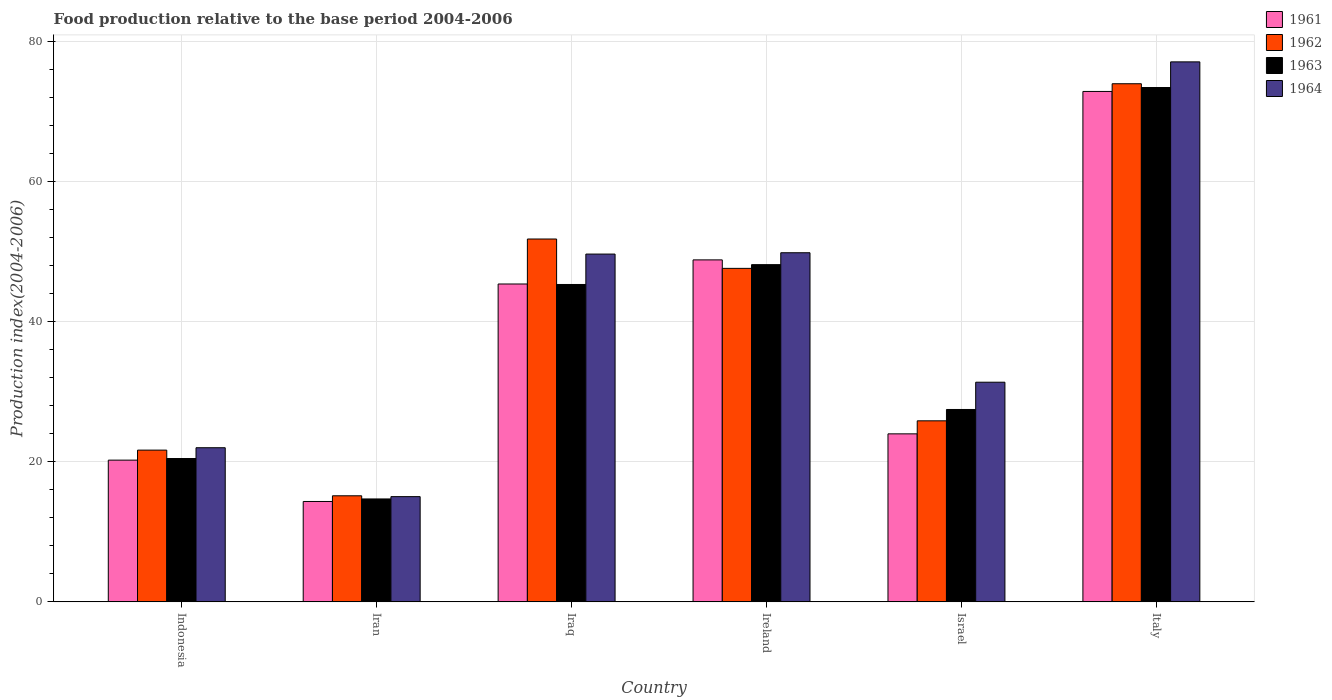How many different coloured bars are there?
Give a very brief answer. 4. Are the number of bars per tick equal to the number of legend labels?
Your answer should be compact. Yes. How many bars are there on the 2nd tick from the right?
Make the answer very short. 4. What is the label of the 5th group of bars from the left?
Your answer should be compact. Israel. What is the food production index in 1963 in Israel?
Keep it short and to the point. 27.46. Across all countries, what is the maximum food production index in 1962?
Make the answer very short. 73.95. Across all countries, what is the minimum food production index in 1964?
Your answer should be compact. 15.02. In which country was the food production index in 1964 minimum?
Provide a short and direct response. Iran. What is the total food production index in 1961 in the graph?
Give a very brief answer. 225.57. What is the difference between the food production index in 1961 in Indonesia and that in Israel?
Keep it short and to the point. -3.75. What is the difference between the food production index in 1963 in Iran and the food production index in 1964 in Israel?
Offer a very short reply. -16.66. What is the average food production index in 1963 per country?
Your response must be concise. 38.24. What is the difference between the food production index of/in 1962 and food production index of/in 1964 in Ireland?
Make the answer very short. -2.23. What is the ratio of the food production index in 1961 in Iraq to that in Ireland?
Provide a succinct answer. 0.93. Is the food production index in 1961 in Indonesia less than that in Iraq?
Keep it short and to the point. Yes. What is the difference between the highest and the second highest food production index in 1964?
Provide a succinct answer. -27.24. What is the difference between the highest and the lowest food production index in 1963?
Offer a very short reply. 58.72. In how many countries, is the food production index in 1963 greater than the average food production index in 1963 taken over all countries?
Provide a short and direct response. 3. Is the sum of the food production index in 1961 in Iran and Italy greater than the maximum food production index in 1964 across all countries?
Give a very brief answer. Yes. What does the 4th bar from the left in Iran represents?
Keep it short and to the point. 1964. What does the 2nd bar from the right in Iran represents?
Keep it short and to the point. 1963. How many bars are there?
Ensure brevity in your answer.  24. Are all the bars in the graph horizontal?
Ensure brevity in your answer.  No. What is the difference between two consecutive major ticks on the Y-axis?
Offer a very short reply. 20. Are the values on the major ticks of Y-axis written in scientific E-notation?
Give a very brief answer. No. How are the legend labels stacked?
Make the answer very short. Vertical. What is the title of the graph?
Give a very brief answer. Food production relative to the base period 2004-2006. What is the label or title of the X-axis?
Offer a very short reply. Country. What is the label or title of the Y-axis?
Offer a very short reply. Production index(2004-2006). What is the Production index(2004-2006) of 1961 in Indonesia?
Your answer should be very brief. 20.23. What is the Production index(2004-2006) in 1962 in Indonesia?
Offer a very short reply. 21.66. What is the Production index(2004-2006) of 1963 in Indonesia?
Ensure brevity in your answer.  20.46. What is the Production index(2004-2006) of 1964 in Indonesia?
Offer a very short reply. 22. What is the Production index(2004-2006) in 1961 in Iran?
Provide a succinct answer. 14.33. What is the Production index(2004-2006) in 1962 in Iran?
Your response must be concise. 15.14. What is the Production index(2004-2006) in 1963 in Iran?
Provide a succinct answer. 14.69. What is the Production index(2004-2006) of 1964 in Iran?
Your response must be concise. 15.02. What is the Production index(2004-2006) of 1961 in Iraq?
Your response must be concise. 45.37. What is the Production index(2004-2006) of 1962 in Iraq?
Provide a succinct answer. 51.79. What is the Production index(2004-2006) in 1963 in Iraq?
Ensure brevity in your answer.  45.3. What is the Production index(2004-2006) of 1964 in Iraq?
Offer a terse response. 49.64. What is the Production index(2004-2006) in 1961 in Ireland?
Your response must be concise. 48.81. What is the Production index(2004-2006) of 1962 in Ireland?
Your response must be concise. 47.6. What is the Production index(2004-2006) in 1963 in Ireland?
Make the answer very short. 48.13. What is the Production index(2004-2006) of 1964 in Ireland?
Give a very brief answer. 49.83. What is the Production index(2004-2006) in 1961 in Israel?
Your answer should be very brief. 23.98. What is the Production index(2004-2006) in 1962 in Israel?
Make the answer very short. 25.84. What is the Production index(2004-2006) in 1963 in Israel?
Keep it short and to the point. 27.46. What is the Production index(2004-2006) in 1964 in Israel?
Offer a terse response. 31.35. What is the Production index(2004-2006) of 1961 in Italy?
Provide a short and direct response. 72.85. What is the Production index(2004-2006) in 1962 in Italy?
Your answer should be compact. 73.95. What is the Production index(2004-2006) of 1963 in Italy?
Provide a short and direct response. 73.41. What is the Production index(2004-2006) of 1964 in Italy?
Make the answer very short. 77.07. Across all countries, what is the maximum Production index(2004-2006) in 1961?
Your answer should be compact. 72.85. Across all countries, what is the maximum Production index(2004-2006) of 1962?
Ensure brevity in your answer.  73.95. Across all countries, what is the maximum Production index(2004-2006) of 1963?
Make the answer very short. 73.41. Across all countries, what is the maximum Production index(2004-2006) in 1964?
Provide a short and direct response. 77.07. Across all countries, what is the minimum Production index(2004-2006) in 1961?
Give a very brief answer. 14.33. Across all countries, what is the minimum Production index(2004-2006) of 1962?
Provide a succinct answer. 15.14. Across all countries, what is the minimum Production index(2004-2006) in 1963?
Provide a succinct answer. 14.69. Across all countries, what is the minimum Production index(2004-2006) of 1964?
Your answer should be compact. 15.02. What is the total Production index(2004-2006) in 1961 in the graph?
Keep it short and to the point. 225.57. What is the total Production index(2004-2006) in 1962 in the graph?
Offer a terse response. 235.98. What is the total Production index(2004-2006) of 1963 in the graph?
Give a very brief answer. 229.45. What is the total Production index(2004-2006) in 1964 in the graph?
Provide a succinct answer. 244.91. What is the difference between the Production index(2004-2006) in 1962 in Indonesia and that in Iran?
Provide a short and direct response. 6.52. What is the difference between the Production index(2004-2006) in 1963 in Indonesia and that in Iran?
Provide a succinct answer. 5.77. What is the difference between the Production index(2004-2006) in 1964 in Indonesia and that in Iran?
Provide a succinct answer. 6.98. What is the difference between the Production index(2004-2006) in 1961 in Indonesia and that in Iraq?
Your response must be concise. -25.14. What is the difference between the Production index(2004-2006) of 1962 in Indonesia and that in Iraq?
Make the answer very short. -30.13. What is the difference between the Production index(2004-2006) of 1963 in Indonesia and that in Iraq?
Offer a very short reply. -24.84. What is the difference between the Production index(2004-2006) in 1964 in Indonesia and that in Iraq?
Offer a terse response. -27.64. What is the difference between the Production index(2004-2006) of 1961 in Indonesia and that in Ireland?
Your answer should be very brief. -28.58. What is the difference between the Production index(2004-2006) in 1962 in Indonesia and that in Ireland?
Your answer should be compact. -25.94. What is the difference between the Production index(2004-2006) in 1963 in Indonesia and that in Ireland?
Give a very brief answer. -27.67. What is the difference between the Production index(2004-2006) in 1964 in Indonesia and that in Ireland?
Provide a short and direct response. -27.83. What is the difference between the Production index(2004-2006) of 1961 in Indonesia and that in Israel?
Offer a very short reply. -3.75. What is the difference between the Production index(2004-2006) in 1962 in Indonesia and that in Israel?
Offer a very short reply. -4.18. What is the difference between the Production index(2004-2006) in 1964 in Indonesia and that in Israel?
Give a very brief answer. -9.35. What is the difference between the Production index(2004-2006) of 1961 in Indonesia and that in Italy?
Your answer should be very brief. -52.62. What is the difference between the Production index(2004-2006) in 1962 in Indonesia and that in Italy?
Your answer should be compact. -52.29. What is the difference between the Production index(2004-2006) in 1963 in Indonesia and that in Italy?
Offer a very short reply. -52.95. What is the difference between the Production index(2004-2006) of 1964 in Indonesia and that in Italy?
Provide a succinct answer. -55.07. What is the difference between the Production index(2004-2006) in 1961 in Iran and that in Iraq?
Provide a short and direct response. -31.04. What is the difference between the Production index(2004-2006) of 1962 in Iran and that in Iraq?
Provide a short and direct response. -36.65. What is the difference between the Production index(2004-2006) of 1963 in Iran and that in Iraq?
Provide a short and direct response. -30.61. What is the difference between the Production index(2004-2006) in 1964 in Iran and that in Iraq?
Provide a succinct answer. -34.62. What is the difference between the Production index(2004-2006) of 1961 in Iran and that in Ireland?
Ensure brevity in your answer.  -34.48. What is the difference between the Production index(2004-2006) of 1962 in Iran and that in Ireland?
Give a very brief answer. -32.46. What is the difference between the Production index(2004-2006) in 1963 in Iran and that in Ireland?
Provide a short and direct response. -33.44. What is the difference between the Production index(2004-2006) in 1964 in Iran and that in Ireland?
Offer a very short reply. -34.81. What is the difference between the Production index(2004-2006) of 1961 in Iran and that in Israel?
Give a very brief answer. -9.65. What is the difference between the Production index(2004-2006) of 1963 in Iran and that in Israel?
Provide a short and direct response. -12.77. What is the difference between the Production index(2004-2006) of 1964 in Iran and that in Israel?
Keep it short and to the point. -16.33. What is the difference between the Production index(2004-2006) in 1961 in Iran and that in Italy?
Provide a short and direct response. -58.52. What is the difference between the Production index(2004-2006) in 1962 in Iran and that in Italy?
Your answer should be very brief. -58.81. What is the difference between the Production index(2004-2006) of 1963 in Iran and that in Italy?
Give a very brief answer. -58.72. What is the difference between the Production index(2004-2006) of 1964 in Iran and that in Italy?
Your response must be concise. -62.05. What is the difference between the Production index(2004-2006) in 1961 in Iraq and that in Ireland?
Provide a short and direct response. -3.44. What is the difference between the Production index(2004-2006) in 1962 in Iraq and that in Ireland?
Keep it short and to the point. 4.19. What is the difference between the Production index(2004-2006) in 1963 in Iraq and that in Ireland?
Ensure brevity in your answer.  -2.83. What is the difference between the Production index(2004-2006) of 1964 in Iraq and that in Ireland?
Your response must be concise. -0.19. What is the difference between the Production index(2004-2006) in 1961 in Iraq and that in Israel?
Ensure brevity in your answer.  21.39. What is the difference between the Production index(2004-2006) of 1962 in Iraq and that in Israel?
Make the answer very short. 25.95. What is the difference between the Production index(2004-2006) of 1963 in Iraq and that in Israel?
Offer a terse response. 17.84. What is the difference between the Production index(2004-2006) of 1964 in Iraq and that in Israel?
Ensure brevity in your answer.  18.29. What is the difference between the Production index(2004-2006) of 1961 in Iraq and that in Italy?
Your response must be concise. -27.48. What is the difference between the Production index(2004-2006) in 1962 in Iraq and that in Italy?
Offer a terse response. -22.16. What is the difference between the Production index(2004-2006) in 1963 in Iraq and that in Italy?
Provide a succinct answer. -28.11. What is the difference between the Production index(2004-2006) in 1964 in Iraq and that in Italy?
Ensure brevity in your answer.  -27.43. What is the difference between the Production index(2004-2006) in 1961 in Ireland and that in Israel?
Offer a very short reply. 24.83. What is the difference between the Production index(2004-2006) in 1962 in Ireland and that in Israel?
Your response must be concise. 21.76. What is the difference between the Production index(2004-2006) of 1963 in Ireland and that in Israel?
Your answer should be compact. 20.67. What is the difference between the Production index(2004-2006) in 1964 in Ireland and that in Israel?
Your answer should be very brief. 18.48. What is the difference between the Production index(2004-2006) in 1961 in Ireland and that in Italy?
Keep it short and to the point. -24.04. What is the difference between the Production index(2004-2006) in 1962 in Ireland and that in Italy?
Ensure brevity in your answer.  -26.35. What is the difference between the Production index(2004-2006) in 1963 in Ireland and that in Italy?
Your response must be concise. -25.28. What is the difference between the Production index(2004-2006) of 1964 in Ireland and that in Italy?
Offer a very short reply. -27.24. What is the difference between the Production index(2004-2006) of 1961 in Israel and that in Italy?
Give a very brief answer. -48.87. What is the difference between the Production index(2004-2006) of 1962 in Israel and that in Italy?
Provide a short and direct response. -48.11. What is the difference between the Production index(2004-2006) of 1963 in Israel and that in Italy?
Keep it short and to the point. -45.95. What is the difference between the Production index(2004-2006) in 1964 in Israel and that in Italy?
Your answer should be compact. -45.72. What is the difference between the Production index(2004-2006) in 1961 in Indonesia and the Production index(2004-2006) in 1962 in Iran?
Give a very brief answer. 5.09. What is the difference between the Production index(2004-2006) of 1961 in Indonesia and the Production index(2004-2006) of 1963 in Iran?
Ensure brevity in your answer.  5.54. What is the difference between the Production index(2004-2006) in 1961 in Indonesia and the Production index(2004-2006) in 1964 in Iran?
Ensure brevity in your answer.  5.21. What is the difference between the Production index(2004-2006) in 1962 in Indonesia and the Production index(2004-2006) in 1963 in Iran?
Your response must be concise. 6.97. What is the difference between the Production index(2004-2006) in 1962 in Indonesia and the Production index(2004-2006) in 1964 in Iran?
Your response must be concise. 6.64. What is the difference between the Production index(2004-2006) in 1963 in Indonesia and the Production index(2004-2006) in 1964 in Iran?
Your answer should be compact. 5.44. What is the difference between the Production index(2004-2006) in 1961 in Indonesia and the Production index(2004-2006) in 1962 in Iraq?
Offer a very short reply. -31.56. What is the difference between the Production index(2004-2006) of 1961 in Indonesia and the Production index(2004-2006) of 1963 in Iraq?
Ensure brevity in your answer.  -25.07. What is the difference between the Production index(2004-2006) of 1961 in Indonesia and the Production index(2004-2006) of 1964 in Iraq?
Ensure brevity in your answer.  -29.41. What is the difference between the Production index(2004-2006) of 1962 in Indonesia and the Production index(2004-2006) of 1963 in Iraq?
Provide a short and direct response. -23.64. What is the difference between the Production index(2004-2006) in 1962 in Indonesia and the Production index(2004-2006) in 1964 in Iraq?
Provide a succinct answer. -27.98. What is the difference between the Production index(2004-2006) of 1963 in Indonesia and the Production index(2004-2006) of 1964 in Iraq?
Your answer should be compact. -29.18. What is the difference between the Production index(2004-2006) in 1961 in Indonesia and the Production index(2004-2006) in 1962 in Ireland?
Your answer should be very brief. -27.37. What is the difference between the Production index(2004-2006) in 1961 in Indonesia and the Production index(2004-2006) in 1963 in Ireland?
Your response must be concise. -27.9. What is the difference between the Production index(2004-2006) of 1961 in Indonesia and the Production index(2004-2006) of 1964 in Ireland?
Offer a very short reply. -29.6. What is the difference between the Production index(2004-2006) of 1962 in Indonesia and the Production index(2004-2006) of 1963 in Ireland?
Your response must be concise. -26.47. What is the difference between the Production index(2004-2006) of 1962 in Indonesia and the Production index(2004-2006) of 1964 in Ireland?
Make the answer very short. -28.17. What is the difference between the Production index(2004-2006) of 1963 in Indonesia and the Production index(2004-2006) of 1964 in Ireland?
Ensure brevity in your answer.  -29.37. What is the difference between the Production index(2004-2006) in 1961 in Indonesia and the Production index(2004-2006) in 1962 in Israel?
Your answer should be compact. -5.61. What is the difference between the Production index(2004-2006) in 1961 in Indonesia and the Production index(2004-2006) in 1963 in Israel?
Your response must be concise. -7.23. What is the difference between the Production index(2004-2006) of 1961 in Indonesia and the Production index(2004-2006) of 1964 in Israel?
Ensure brevity in your answer.  -11.12. What is the difference between the Production index(2004-2006) in 1962 in Indonesia and the Production index(2004-2006) in 1963 in Israel?
Make the answer very short. -5.8. What is the difference between the Production index(2004-2006) of 1962 in Indonesia and the Production index(2004-2006) of 1964 in Israel?
Make the answer very short. -9.69. What is the difference between the Production index(2004-2006) in 1963 in Indonesia and the Production index(2004-2006) in 1964 in Israel?
Your response must be concise. -10.89. What is the difference between the Production index(2004-2006) of 1961 in Indonesia and the Production index(2004-2006) of 1962 in Italy?
Make the answer very short. -53.72. What is the difference between the Production index(2004-2006) in 1961 in Indonesia and the Production index(2004-2006) in 1963 in Italy?
Give a very brief answer. -53.18. What is the difference between the Production index(2004-2006) in 1961 in Indonesia and the Production index(2004-2006) in 1964 in Italy?
Keep it short and to the point. -56.84. What is the difference between the Production index(2004-2006) in 1962 in Indonesia and the Production index(2004-2006) in 1963 in Italy?
Provide a short and direct response. -51.75. What is the difference between the Production index(2004-2006) in 1962 in Indonesia and the Production index(2004-2006) in 1964 in Italy?
Your response must be concise. -55.41. What is the difference between the Production index(2004-2006) of 1963 in Indonesia and the Production index(2004-2006) of 1964 in Italy?
Provide a short and direct response. -56.61. What is the difference between the Production index(2004-2006) in 1961 in Iran and the Production index(2004-2006) in 1962 in Iraq?
Your answer should be compact. -37.46. What is the difference between the Production index(2004-2006) of 1961 in Iran and the Production index(2004-2006) of 1963 in Iraq?
Provide a short and direct response. -30.97. What is the difference between the Production index(2004-2006) in 1961 in Iran and the Production index(2004-2006) in 1964 in Iraq?
Offer a very short reply. -35.31. What is the difference between the Production index(2004-2006) of 1962 in Iran and the Production index(2004-2006) of 1963 in Iraq?
Your answer should be very brief. -30.16. What is the difference between the Production index(2004-2006) in 1962 in Iran and the Production index(2004-2006) in 1964 in Iraq?
Keep it short and to the point. -34.5. What is the difference between the Production index(2004-2006) of 1963 in Iran and the Production index(2004-2006) of 1964 in Iraq?
Provide a succinct answer. -34.95. What is the difference between the Production index(2004-2006) of 1961 in Iran and the Production index(2004-2006) of 1962 in Ireland?
Ensure brevity in your answer.  -33.27. What is the difference between the Production index(2004-2006) in 1961 in Iran and the Production index(2004-2006) in 1963 in Ireland?
Your response must be concise. -33.8. What is the difference between the Production index(2004-2006) of 1961 in Iran and the Production index(2004-2006) of 1964 in Ireland?
Offer a terse response. -35.5. What is the difference between the Production index(2004-2006) of 1962 in Iran and the Production index(2004-2006) of 1963 in Ireland?
Ensure brevity in your answer.  -32.99. What is the difference between the Production index(2004-2006) in 1962 in Iran and the Production index(2004-2006) in 1964 in Ireland?
Your response must be concise. -34.69. What is the difference between the Production index(2004-2006) of 1963 in Iran and the Production index(2004-2006) of 1964 in Ireland?
Make the answer very short. -35.14. What is the difference between the Production index(2004-2006) of 1961 in Iran and the Production index(2004-2006) of 1962 in Israel?
Your answer should be compact. -11.51. What is the difference between the Production index(2004-2006) of 1961 in Iran and the Production index(2004-2006) of 1963 in Israel?
Ensure brevity in your answer.  -13.13. What is the difference between the Production index(2004-2006) in 1961 in Iran and the Production index(2004-2006) in 1964 in Israel?
Provide a short and direct response. -17.02. What is the difference between the Production index(2004-2006) of 1962 in Iran and the Production index(2004-2006) of 1963 in Israel?
Your response must be concise. -12.32. What is the difference between the Production index(2004-2006) in 1962 in Iran and the Production index(2004-2006) in 1964 in Israel?
Your answer should be very brief. -16.21. What is the difference between the Production index(2004-2006) of 1963 in Iran and the Production index(2004-2006) of 1964 in Israel?
Your answer should be very brief. -16.66. What is the difference between the Production index(2004-2006) in 1961 in Iran and the Production index(2004-2006) in 1962 in Italy?
Keep it short and to the point. -59.62. What is the difference between the Production index(2004-2006) of 1961 in Iran and the Production index(2004-2006) of 1963 in Italy?
Provide a short and direct response. -59.08. What is the difference between the Production index(2004-2006) of 1961 in Iran and the Production index(2004-2006) of 1964 in Italy?
Your response must be concise. -62.74. What is the difference between the Production index(2004-2006) of 1962 in Iran and the Production index(2004-2006) of 1963 in Italy?
Offer a very short reply. -58.27. What is the difference between the Production index(2004-2006) in 1962 in Iran and the Production index(2004-2006) in 1964 in Italy?
Your answer should be very brief. -61.93. What is the difference between the Production index(2004-2006) in 1963 in Iran and the Production index(2004-2006) in 1964 in Italy?
Give a very brief answer. -62.38. What is the difference between the Production index(2004-2006) in 1961 in Iraq and the Production index(2004-2006) in 1962 in Ireland?
Your answer should be very brief. -2.23. What is the difference between the Production index(2004-2006) of 1961 in Iraq and the Production index(2004-2006) of 1963 in Ireland?
Make the answer very short. -2.76. What is the difference between the Production index(2004-2006) of 1961 in Iraq and the Production index(2004-2006) of 1964 in Ireland?
Offer a terse response. -4.46. What is the difference between the Production index(2004-2006) in 1962 in Iraq and the Production index(2004-2006) in 1963 in Ireland?
Offer a terse response. 3.66. What is the difference between the Production index(2004-2006) in 1962 in Iraq and the Production index(2004-2006) in 1964 in Ireland?
Ensure brevity in your answer.  1.96. What is the difference between the Production index(2004-2006) of 1963 in Iraq and the Production index(2004-2006) of 1964 in Ireland?
Ensure brevity in your answer.  -4.53. What is the difference between the Production index(2004-2006) of 1961 in Iraq and the Production index(2004-2006) of 1962 in Israel?
Give a very brief answer. 19.53. What is the difference between the Production index(2004-2006) in 1961 in Iraq and the Production index(2004-2006) in 1963 in Israel?
Give a very brief answer. 17.91. What is the difference between the Production index(2004-2006) of 1961 in Iraq and the Production index(2004-2006) of 1964 in Israel?
Offer a very short reply. 14.02. What is the difference between the Production index(2004-2006) of 1962 in Iraq and the Production index(2004-2006) of 1963 in Israel?
Make the answer very short. 24.33. What is the difference between the Production index(2004-2006) of 1962 in Iraq and the Production index(2004-2006) of 1964 in Israel?
Give a very brief answer. 20.44. What is the difference between the Production index(2004-2006) of 1963 in Iraq and the Production index(2004-2006) of 1964 in Israel?
Your response must be concise. 13.95. What is the difference between the Production index(2004-2006) in 1961 in Iraq and the Production index(2004-2006) in 1962 in Italy?
Your response must be concise. -28.58. What is the difference between the Production index(2004-2006) of 1961 in Iraq and the Production index(2004-2006) of 1963 in Italy?
Make the answer very short. -28.04. What is the difference between the Production index(2004-2006) of 1961 in Iraq and the Production index(2004-2006) of 1964 in Italy?
Offer a terse response. -31.7. What is the difference between the Production index(2004-2006) in 1962 in Iraq and the Production index(2004-2006) in 1963 in Italy?
Provide a short and direct response. -21.62. What is the difference between the Production index(2004-2006) of 1962 in Iraq and the Production index(2004-2006) of 1964 in Italy?
Offer a terse response. -25.28. What is the difference between the Production index(2004-2006) in 1963 in Iraq and the Production index(2004-2006) in 1964 in Italy?
Offer a very short reply. -31.77. What is the difference between the Production index(2004-2006) of 1961 in Ireland and the Production index(2004-2006) of 1962 in Israel?
Offer a terse response. 22.97. What is the difference between the Production index(2004-2006) of 1961 in Ireland and the Production index(2004-2006) of 1963 in Israel?
Your response must be concise. 21.35. What is the difference between the Production index(2004-2006) in 1961 in Ireland and the Production index(2004-2006) in 1964 in Israel?
Offer a very short reply. 17.46. What is the difference between the Production index(2004-2006) of 1962 in Ireland and the Production index(2004-2006) of 1963 in Israel?
Keep it short and to the point. 20.14. What is the difference between the Production index(2004-2006) in 1962 in Ireland and the Production index(2004-2006) in 1964 in Israel?
Keep it short and to the point. 16.25. What is the difference between the Production index(2004-2006) in 1963 in Ireland and the Production index(2004-2006) in 1964 in Israel?
Your answer should be compact. 16.78. What is the difference between the Production index(2004-2006) in 1961 in Ireland and the Production index(2004-2006) in 1962 in Italy?
Offer a terse response. -25.14. What is the difference between the Production index(2004-2006) of 1961 in Ireland and the Production index(2004-2006) of 1963 in Italy?
Make the answer very short. -24.6. What is the difference between the Production index(2004-2006) in 1961 in Ireland and the Production index(2004-2006) in 1964 in Italy?
Your response must be concise. -28.26. What is the difference between the Production index(2004-2006) of 1962 in Ireland and the Production index(2004-2006) of 1963 in Italy?
Your response must be concise. -25.81. What is the difference between the Production index(2004-2006) of 1962 in Ireland and the Production index(2004-2006) of 1964 in Italy?
Ensure brevity in your answer.  -29.47. What is the difference between the Production index(2004-2006) in 1963 in Ireland and the Production index(2004-2006) in 1964 in Italy?
Give a very brief answer. -28.94. What is the difference between the Production index(2004-2006) of 1961 in Israel and the Production index(2004-2006) of 1962 in Italy?
Make the answer very short. -49.97. What is the difference between the Production index(2004-2006) in 1961 in Israel and the Production index(2004-2006) in 1963 in Italy?
Your response must be concise. -49.43. What is the difference between the Production index(2004-2006) in 1961 in Israel and the Production index(2004-2006) in 1964 in Italy?
Your answer should be very brief. -53.09. What is the difference between the Production index(2004-2006) in 1962 in Israel and the Production index(2004-2006) in 1963 in Italy?
Your answer should be compact. -47.57. What is the difference between the Production index(2004-2006) in 1962 in Israel and the Production index(2004-2006) in 1964 in Italy?
Your response must be concise. -51.23. What is the difference between the Production index(2004-2006) of 1963 in Israel and the Production index(2004-2006) of 1964 in Italy?
Ensure brevity in your answer.  -49.61. What is the average Production index(2004-2006) in 1961 per country?
Provide a succinct answer. 37.59. What is the average Production index(2004-2006) of 1962 per country?
Provide a succinct answer. 39.33. What is the average Production index(2004-2006) in 1963 per country?
Give a very brief answer. 38.24. What is the average Production index(2004-2006) of 1964 per country?
Give a very brief answer. 40.82. What is the difference between the Production index(2004-2006) in 1961 and Production index(2004-2006) in 1962 in Indonesia?
Provide a succinct answer. -1.43. What is the difference between the Production index(2004-2006) in 1961 and Production index(2004-2006) in 1963 in Indonesia?
Ensure brevity in your answer.  -0.23. What is the difference between the Production index(2004-2006) of 1961 and Production index(2004-2006) of 1964 in Indonesia?
Your answer should be compact. -1.77. What is the difference between the Production index(2004-2006) in 1962 and Production index(2004-2006) in 1964 in Indonesia?
Provide a succinct answer. -0.34. What is the difference between the Production index(2004-2006) in 1963 and Production index(2004-2006) in 1964 in Indonesia?
Provide a short and direct response. -1.54. What is the difference between the Production index(2004-2006) in 1961 and Production index(2004-2006) in 1962 in Iran?
Give a very brief answer. -0.81. What is the difference between the Production index(2004-2006) in 1961 and Production index(2004-2006) in 1963 in Iran?
Offer a terse response. -0.36. What is the difference between the Production index(2004-2006) of 1961 and Production index(2004-2006) of 1964 in Iran?
Your response must be concise. -0.69. What is the difference between the Production index(2004-2006) in 1962 and Production index(2004-2006) in 1963 in Iran?
Your response must be concise. 0.45. What is the difference between the Production index(2004-2006) of 1962 and Production index(2004-2006) of 1964 in Iran?
Make the answer very short. 0.12. What is the difference between the Production index(2004-2006) in 1963 and Production index(2004-2006) in 1964 in Iran?
Offer a very short reply. -0.33. What is the difference between the Production index(2004-2006) of 1961 and Production index(2004-2006) of 1962 in Iraq?
Ensure brevity in your answer.  -6.42. What is the difference between the Production index(2004-2006) in 1961 and Production index(2004-2006) in 1963 in Iraq?
Your response must be concise. 0.07. What is the difference between the Production index(2004-2006) in 1961 and Production index(2004-2006) in 1964 in Iraq?
Ensure brevity in your answer.  -4.27. What is the difference between the Production index(2004-2006) in 1962 and Production index(2004-2006) in 1963 in Iraq?
Provide a succinct answer. 6.49. What is the difference between the Production index(2004-2006) of 1962 and Production index(2004-2006) of 1964 in Iraq?
Your answer should be very brief. 2.15. What is the difference between the Production index(2004-2006) in 1963 and Production index(2004-2006) in 1964 in Iraq?
Give a very brief answer. -4.34. What is the difference between the Production index(2004-2006) in 1961 and Production index(2004-2006) in 1962 in Ireland?
Offer a very short reply. 1.21. What is the difference between the Production index(2004-2006) in 1961 and Production index(2004-2006) in 1963 in Ireland?
Offer a terse response. 0.68. What is the difference between the Production index(2004-2006) of 1961 and Production index(2004-2006) of 1964 in Ireland?
Your answer should be very brief. -1.02. What is the difference between the Production index(2004-2006) of 1962 and Production index(2004-2006) of 1963 in Ireland?
Your answer should be very brief. -0.53. What is the difference between the Production index(2004-2006) in 1962 and Production index(2004-2006) in 1964 in Ireland?
Your answer should be very brief. -2.23. What is the difference between the Production index(2004-2006) of 1961 and Production index(2004-2006) of 1962 in Israel?
Give a very brief answer. -1.86. What is the difference between the Production index(2004-2006) of 1961 and Production index(2004-2006) of 1963 in Israel?
Your answer should be very brief. -3.48. What is the difference between the Production index(2004-2006) of 1961 and Production index(2004-2006) of 1964 in Israel?
Keep it short and to the point. -7.37. What is the difference between the Production index(2004-2006) in 1962 and Production index(2004-2006) in 1963 in Israel?
Your response must be concise. -1.62. What is the difference between the Production index(2004-2006) of 1962 and Production index(2004-2006) of 1964 in Israel?
Provide a short and direct response. -5.51. What is the difference between the Production index(2004-2006) of 1963 and Production index(2004-2006) of 1964 in Israel?
Provide a succinct answer. -3.89. What is the difference between the Production index(2004-2006) of 1961 and Production index(2004-2006) of 1963 in Italy?
Offer a terse response. -0.56. What is the difference between the Production index(2004-2006) in 1961 and Production index(2004-2006) in 1964 in Italy?
Your response must be concise. -4.22. What is the difference between the Production index(2004-2006) in 1962 and Production index(2004-2006) in 1963 in Italy?
Your answer should be compact. 0.54. What is the difference between the Production index(2004-2006) in 1962 and Production index(2004-2006) in 1964 in Italy?
Your answer should be very brief. -3.12. What is the difference between the Production index(2004-2006) in 1963 and Production index(2004-2006) in 1964 in Italy?
Offer a terse response. -3.66. What is the ratio of the Production index(2004-2006) in 1961 in Indonesia to that in Iran?
Offer a very short reply. 1.41. What is the ratio of the Production index(2004-2006) in 1962 in Indonesia to that in Iran?
Keep it short and to the point. 1.43. What is the ratio of the Production index(2004-2006) in 1963 in Indonesia to that in Iran?
Give a very brief answer. 1.39. What is the ratio of the Production index(2004-2006) in 1964 in Indonesia to that in Iran?
Offer a terse response. 1.46. What is the ratio of the Production index(2004-2006) in 1961 in Indonesia to that in Iraq?
Offer a very short reply. 0.45. What is the ratio of the Production index(2004-2006) in 1962 in Indonesia to that in Iraq?
Keep it short and to the point. 0.42. What is the ratio of the Production index(2004-2006) of 1963 in Indonesia to that in Iraq?
Your answer should be compact. 0.45. What is the ratio of the Production index(2004-2006) in 1964 in Indonesia to that in Iraq?
Offer a terse response. 0.44. What is the ratio of the Production index(2004-2006) of 1961 in Indonesia to that in Ireland?
Ensure brevity in your answer.  0.41. What is the ratio of the Production index(2004-2006) of 1962 in Indonesia to that in Ireland?
Offer a terse response. 0.46. What is the ratio of the Production index(2004-2006) of 1963 in Indonesia to that in Ireland?
Make the answer very short. 0.43. What is the ratio of the Production index(2004-2006) in 1964 in Indonesia to that in Ireland?
Offer a terse response. 0.44. What is the ratio of the Production index(2004-2006) in 1961 in Indonesia to that in Israel?
Ensure brevity in your answer.  0.84. What is the ratio of the Production index(2004-2006) of 1962 in Indonesia to that in Israel?
Give a very brief answer. 0.84. What is the ratio of the Production index(2004-2006) of 1963 in Indonesia to that in Israel?
Keep it short and to the point. 0.75. What is the ratio of the Production index(2004-2006) in 1964 in Indonesia to that in Israel?
Provide a succinct answer. 0.7. What is the ratio of the Production index(2004-2006) in 1961 in Indonesia to that in Italy?
Your answer should be very brief. 0.28. What is the ratio of the Production index(2004-2006) of 1962 in Indonesia to that in Italy?
Make the answer very short. 0.29. What is the ratio of the Production index(2004-2006) in 1963 in Indonesia to that in Italy?
Your answer should be compact. 0.28. What is the ratio of the Production index(2004-2006) in 1964 in Indonesia to that in Italy?
Your response must be concise. 0.29. What is the ratio of the Production index(2004-2006) in 1961 in Iran to that in Iraq?
Keep it short and to the point. 0.32. What is the ratio of the Production index(2004-2006) of 1962 in Iran to that in Iraq?
Offer a very short reply. 0.29. What is the ratio of the Production index(2004-2006) of 1963 in Iran to that in Iraq?
Make the answer very short. 0.32. What is the ratio of the Production index(2004-2006) of 1964 in Iran to that in Iraq?
Offer a terse response. 0.3. What is the ratio of the Production index(2004-2006) of 1961 in Iran to that in Ireland?
Provide a succinct answer. 0.29. What is the ratio of the Production index(2004-2006) in 1962 in Iran to that in Ireland?
Your response must be concise. 0.32. What is the ratio of the Production index(2004-2006) of 1963 in Iran to that in Ireland?
Give a very brief answer. 0.31. What is the ratio of the Production index(2004-2006) of 1964 in Iran to that in Ireland?
Ensure brevity in your answer.  0.3. What is the ratio of the Production index(2004-2006) of 1961 in Iran to that in Israel?
Keep it short and to the point. 0.6. What is the ratio of the Production index(2004-2006) in 1962 in Iran to that in Israel?
Keep it short and to the point. 0.59. What is the ratio of the Production index(2004-2006) of 1963 in Iran to that in Israel?
Ensure brevity in your answer.  0.54. What is the ratio of the Production index(2004-2006) of 1964 in Iran to that in Israel?
Offer a very short reply. 0.48. What is the ratio of the Production index(2004-2006) in 1961 in Iran to that in Italy?
Provide a succinct answer. 0.2. What is the ratio of the Production index(2004-2006) of 1962 in Iran to that in Italy?
Keep it short and to the point. 0.2. What is the ratio of the Production index(2004-2006) of 1963 in Iran to that in Italy?
Provide a succinct answer. 0.2. What is the ratio of the Production index(2004-2006) in 1964 in Iran to that in Italy?
Keep it short and to the point. 0.19. What is the ratio of the Production index(2004-2006) in 1961 in Iraq to that in Ireland?
Your answer should be compact. 0.93. What is the ratio of the Production index(2004-2006) of 1962 in Iraq to that in Ireland?
Your answer should be compact. 1.09. What is the ratio of the Production index(2004-2006) of 1961 in Iraq to that in Israel?
Your answer should be compact. 1.89. What is the ratio of the Production index(2004-2006) of 1962 in Iraq to that in Israel?
Offer a very short reply. 2. What is the ratio of the Production index(2004-2006) in 1963 in Iraq to that in Israel?
Keep it short and to the point. 1.65. What is the ratio of the Production index(2004-2006) of 1964 in Iraq to that in Israel?
Your answer should be very brief. 1.58. What is the ratio of the Production index(2004-2006) of 1961 in Iraq to that in Italy?
Provide a succinct answer. 0.62. What is the ratio of the Production index(2004-2006) of 1962 in Iraq to that in Italy?
Provide a succinct answer. 0.7. What is the ratio of the Production index(2004-2006) of 1963 in Iraq to that in Italy?
Offer a terse response. 0.62. What is the ratio of the Production index(2004-2006) of 1964 in Iraq to that in Italy?
Keep it short and to the point. 0.64. What is the ratio of the Production index(2004-2006) in 1961 in Ireland to that in Israel?
Keep it short and to the point. 2.04. What is the ratio of the Production index(2004-2006) of 1962 in Ireland to that in Israel?
Provide a succinct answer. 1.84. What is the ratio of the Production index(2004-2006) of 1963 in Ireland to that in Israel?
Provide a succinct answer. 1.75. What is the ratio of the Production index(2004-2006) of 1964 in Ireland to that in Israel?
Your answer should be very brief. 1.59. What is the ratio of the Production index(2004-2006) in 1961 in Ireland to that in Italy?
Your answer should be very brief. 0.67. What is the ratio of the Production index(2004-2006) in 1962 in Ireland to that in Italy?
Your response must be concise. 0.64. What is the ratio of the Production index(2004-2006) in 1963 in Ireland to that in Italy?
Make the answer very short. 0.66. What is the ratio of the Production index(2004-2006) of 1964 in Ireland to that in Italy?
Provide a succinct answer. 0.65. What is the ratio of the Production index(2004-2006) of 1961 in Israel to that in Italy?
Offer a terse response. 0.33. What is the ratio of the Production index(2004-2006) of 1962 in Israel to that in Italy?
Offer a terse response. 0.35. What is the ratio of the Production index(2004-2006) of 1963 in Israel to that in Italy?
Your response must be concise. 0.37. What is the ratio of the Production index(2004-2006) of 1964 in Israel to that in Italy?
Offer a terse response. 0.41. What is the difference between the highest and the second highest Production index(2004-2006) of 1961?
Offer a very short reply. 24.04. What is the difference between the highest and the second highest Production index(2004-2006) of 1962?
Offer a terse response. 22.16. What is the difference between the highest and the second highest Production index(2004-2006) of 1963?
Your answer should be very brief. 25.28. What is the difference between the highest and the second highest Production index(2004-2006) in 1964?
Keep it short and to the point. 27.24. What is the difference between the highest and the lowest Production index(2004-2006) of 1961?
Your answer should be compact. 58.52. What is the difference between the highest and the lowest Production index(2004-2006) of 1962?
Make the answer very short. 58.81. What is the difference between the highest and the lowest Production index(2004-2006) of 1963?
Offer a very short reply. 58.72. What is the difference between the highest and the lowest Production index(2004-2006) in 1964?
Make the answer very short. 62.05. 